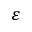<formula> <loc_0><loc_0><loc_500><loc_500>\varepsilon</formula> 